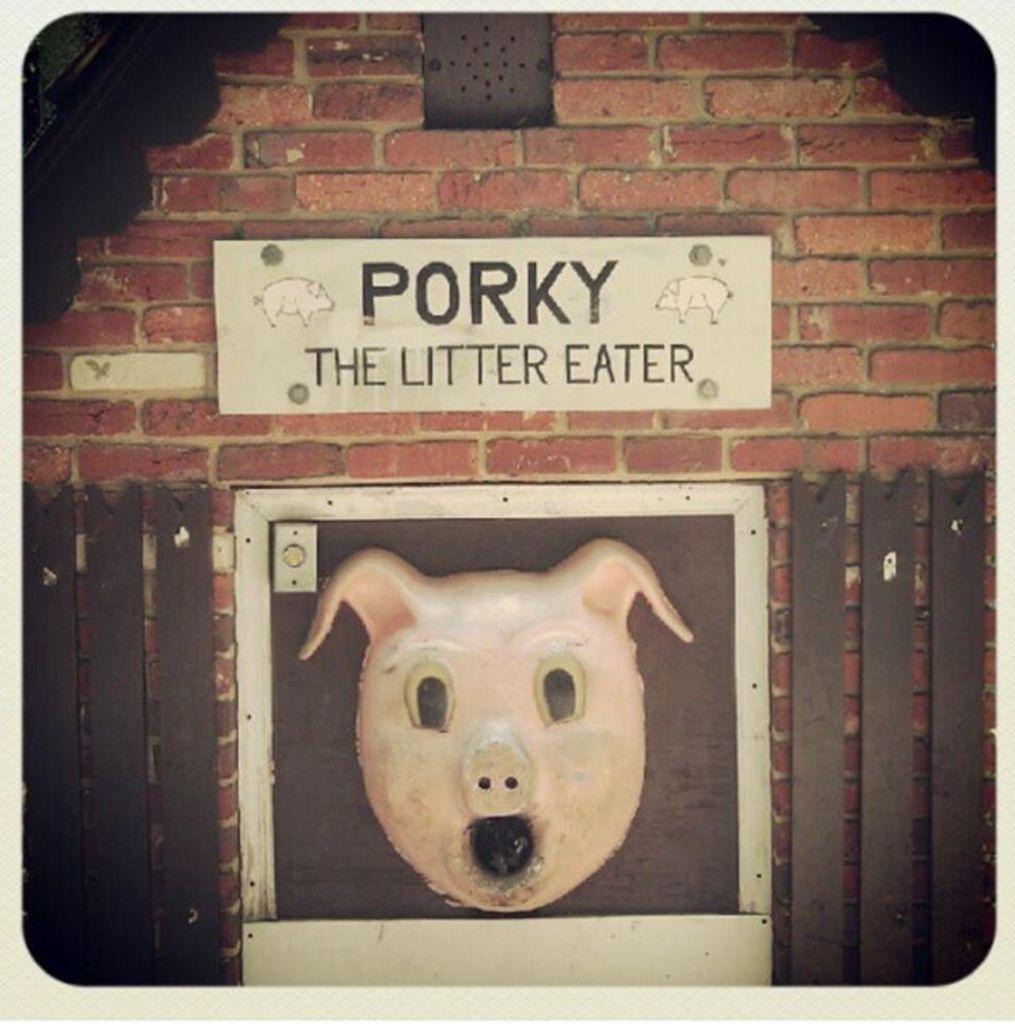Please provide a concise description of this image. In this image, there is a brick wall, there is a white color board on the wall, on that board PORKY THE LITTER EATER is printed, there is a picture of the pork animal at the bottom. 